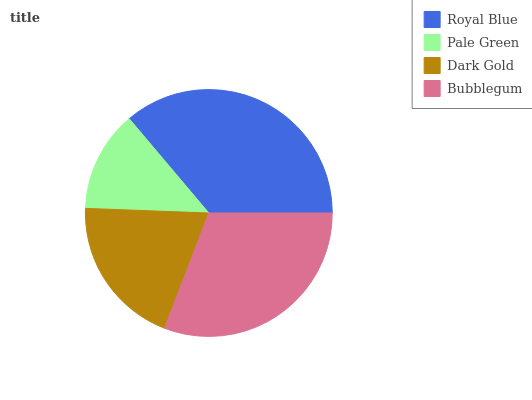Is Pale Green the minimum?
Answer yes or no. Yes. Is Royal Blue the maximum?
Answer yes or no. Yes. Is Dark Gold the minimum?
Answer yes or no. No. Is Dark Gold the maximum?
Answer yes or no. No. Is Dark Gold greater than Pale Green?
Answer yes or no. Yes. Is Pale Green less than Dark Gold?
Answer yes or no. Yes. Is Pale Green greater than Dark Gold?
Answer yes or no. No. Is Dark Gold less than Pale Green?
Answer yes or no. No. Is Bubblegum the high median?
Answer yes or no. Yes. Is Dark Gold the low median?
Answer yes or no. Yes. Is Pale Green the high median?
Answer yes or no. No. Is Pale Green the low median?
Answer yes or no. No. 